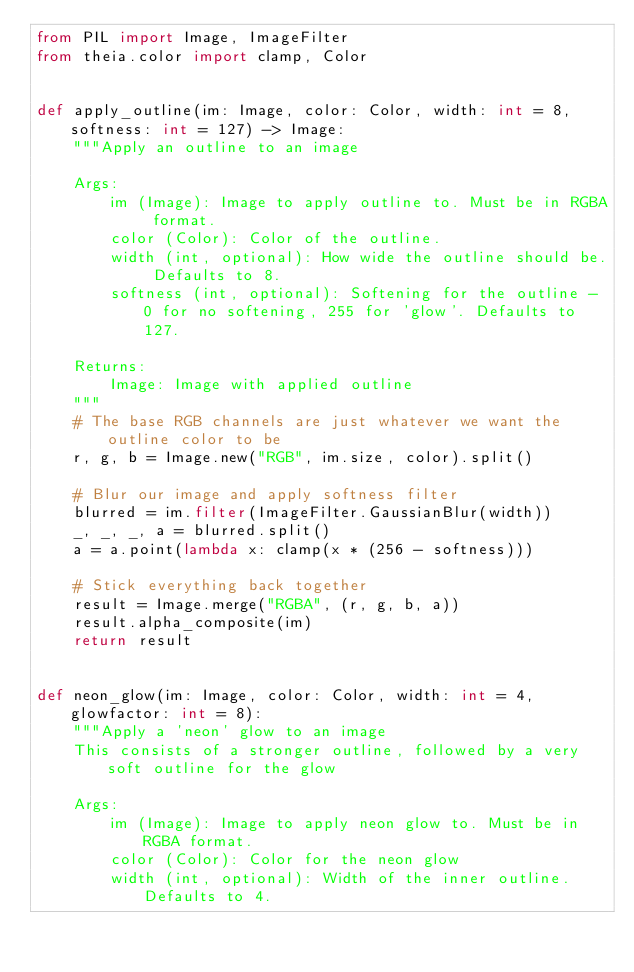Convert code to text. <code><loc_0><loc_0><loc_500><loc_500><_Python_>from PIL import Image, ImageFilter
from theia.color import clamp, Color


def apply_outline(im: Image, color: Color, width: int = 8, softness: int = 127) -> Image:
    """Apply an outline to an image

    Args:
        im (Image): Image to apply outline to. Must be in RGBA format.
        color (Color): Color of the outline.
        width (int, optional): How wide the outline should be. Defaults to 8.
        softness (int, optional): Softening for the outline - 0 for no softening, 255 for 'glow'. Defaults to 127.

    Returns:
        Image: Image with applied outline
    """
    # The base RGB channels are just whatever we want the outline color to be
    r, g, b = Image.new("RGB", im.size, color).split()

    # Blur our image and apply softness filter
    blurred = im.filter(ImageFilter.GaussianBlur(width))
    _, _, _, a = blurred.split()
    a = a.point(lambda x: clamp(x * (256 - softness)))

    # Stick everything back together
    result = Image.merge("RGBA", (r, g, b, a))
    result.alpha_composite(im)
    return result


def neon_glow(im: Image, color: Color, width: int = 4, glowfactor: int = 8):
    """Apply a 'neon' glow to an image
    This consists of a stronger outline, followed by a very soft outline for the glow

    Args:
        im (Image): Image to apply neon glow to. Must be in RGBA format.
        color (Color): Color for the neon glow
        width (int, optional): Width of the inner outline. Defaults to 4.</code> 